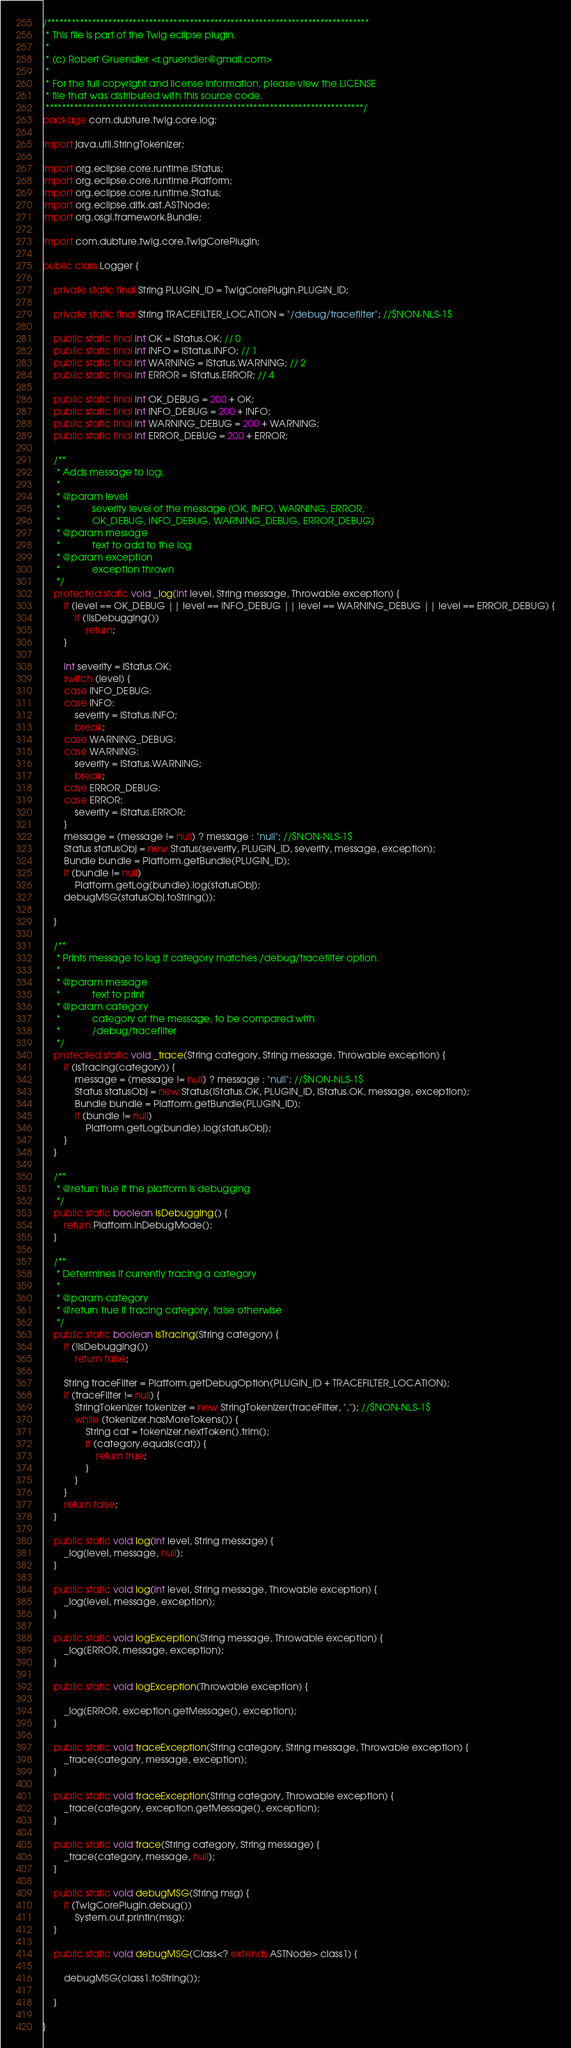<code> <loc_0><loc_0><loc_500><loc_500><_Java_>/*******************************************************************************
 * This file is part of the Twig eclipse plugin.
 * 
 * (c) Robert Gruendler <r.gruendler@gmail.com>
 * 
 * For the full copyright and license information, please view the LICENSE
 * file that was distributed with this source code.
 ******************************************************************************/
package com.dubture.twig.core.log;

import java.util.StringTokenizer;

import org.eclipse.core.runtime.IStatus;
import org.eclipse.core.runtime.Platform;
import org.eclipse.core.runtime.Status;
import org.eclipse.dltk.ast.ASTNode;
import org.osgi.framework.Bundle;

import com.dubture.twig.core.TwigCorePlugin;

public class Logger {

	private static final String PLUGIN_ID = TwigCorePlugin.PLUGIN_ID;

	private static final String TRACEFILTER_LOCATION = "/debug/tracefilter"; //$NON-NLS-1$

	public static final int OK = IStatus.OK; // 0
	public static final int INFO = IStatus.INFO; // 1
	public static final int WARNING = IStatus.WARNING; // 2
	public static final int ERROR = IStatus.ERROR; // 4

	public static final int OK_DEBUG = 200 + OK;
	public static final int INFO_DEBUG = 200 + INFO;
	public static final int WARNING_DEBUG = 200 + WARNING;
	public static final int ERROR_DEBUG = 200 + ERROR;

	/**
	 * Adds message to log.
	 * 
	 * @param level
	 *            severity level of the message (OK, INFO, WARNING, ERROR,
	 *            OK_DEBUG, INFO_DEBUG, WARNING_DEBUG, ERROR_DEBUG)
	 * @param message
	 *            text to add to the log
	 * @param exception
	 *            exception thrown
	 */
	protected static void _log(int level, String message, Throwable exception) {
		if (level == OK_DEBUG || level == INFO_DEBUG || level == WARNING_DEBUG || level == ERROR_DEBUG) {
			if (!isDebugging())
				return;
		}

		int severity = IStatus.OK;
		switch (level) {
		case INFO_DEBUG:
		case INFO:
			severity = IStatus.INFO;
			break;
		case WARNING_DEBUG:
		case WARNING:
			severity = IStatus.WARNING;
			break;
		case ERROR_DEBUG:
		case ERROR:
			severity = IStatus.ERROR;
		}
		message = (message != null) ? message : "null"; //$NON-NLS-1$
		Status statusObj = new Status(severity, PLUGIN_ID, severity, message, exception);
		Bundle bundle = Platform.getBundle(PLUGIN_ID);
		if (bundle != null)
			Platform.getLog(bundle).log(statusObj);
		debugMSG(statusObj.toString());

	}

	/**
	 * Prints message to log if category matches /debug/tracefilter option.
	 * 
	 * @param message
	 *            text to print
	 * @param category
	 *            category of the message, to be compared with
	 *            /debug/tracefilter
	 */
	protected static void _trace(String category, String message, Throwable exception) {
		if (isTracing(category)) {
			message = (message != null) ? message : "null"; //$NON-NLS-1$
			Status statusObj = new Status(IStatus.OK, PLUGIN_ID, IStatus.OK, message, exception);
			Bundle bundle = Platform.getBundle(PLUGIN_ID);
			if (bundle != null)
				Platform.getLog(bundle).log(statusObj);
		}
	}

	/**
	 * @return true if the platform is debugging
	 */
	public static boolean isDebugging() {
		return Platform.inDebugMode();
	}

	/**
	 * Determines if currently tracing a category
	 * 
	 * @param category
	 * @return true if tracing category, false otherwise
	 */
	public static boolean isTracing(String category) {
		if (!isDebugging())
			return false;

		String traceFilter = Platform.getDebugOption(PLUGIN_ID + TRACEFILTER_LOCATION);
		if (traceFilter != null) {
			StringTokenizer tokenizer = new StringTokenizer(traceFilter, ","); //$NON-NLS-1$
			while (tokenizer.hasMoreTokens()) {
				String cat = tokenizer.nextToken().trim();
				if (category.equals(cat)) {
					return true;
				}
			}
		}
		return false;
	}

	public static void log(int level, String message) {
		_log(level, message, null);
	}

	public static void log(int level, String message, Throwable exception) {
		_log(level, message, exception);
	}

	public static void logException(String message, Throwable exception) {
		_log(ERROR, message, exception);
	}

	public static void logException(Throwable exception) {

		_log(ERROR, exception.getMessage(), exception);
	}

	public static void traceException(String category, String message, Throwable exception) {
		_trace(category, message, exception);
	}

	public static void traceException(String category, Throwable exception) {
		_trace(category, exception.getMessage(), exception);
	}

	public static void trace(String category, String message) {
		_trace(category, message, null);
	}

	public static void debugMSG(String msg) {
		if (TwigCorePlugin.debug())
			System.out.println(msg);
	}

	public static void debugMSG(Class<? extends ASTNode> class1) {

		debugMSG(class1.toString());

	}

}
</code> 